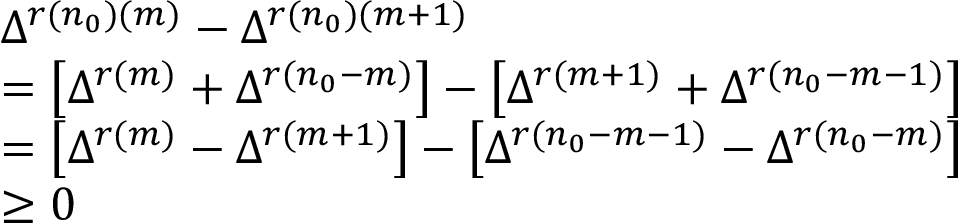Convert formula to latex. <formula><loc_0><loc_0><loc_500><loc_500>\begin{array} { r l } & { \Delta ^ { r ( n _ { 0 } ) ( m ) } - \Delta ^ { r ( n _ { 0 } ) ( m + 1 ) } } \\ & { = \left [ \Delta ^ { r ( m ) } + \Delta ^ { r ( n _ { 0 } - m ) } \right ] - \left [ \Delta ^ { r ( m + 1 ) } + \Delta ^ { r ( n _ { 0 } - m - 1 ) } \right ] } \\ & { = \left [ \Delta ^ { r ( m ) } - \Delta ^ { r ( m + 1 ) } \right ] - \left [ \Delta ^ { r ( n _ { 0 } - m - 1 ) } - \Delta ^ { r ( n _ { 0 } - m ) } \right ] } \\ & { \geq 0 } \end{array}</formula> 